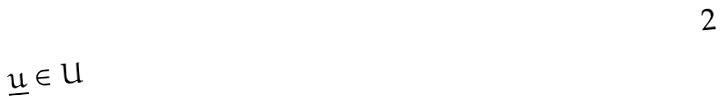<formula> <loc_0><loc_0><loc_500><loc_500>\underline { u } \in U</formula> 